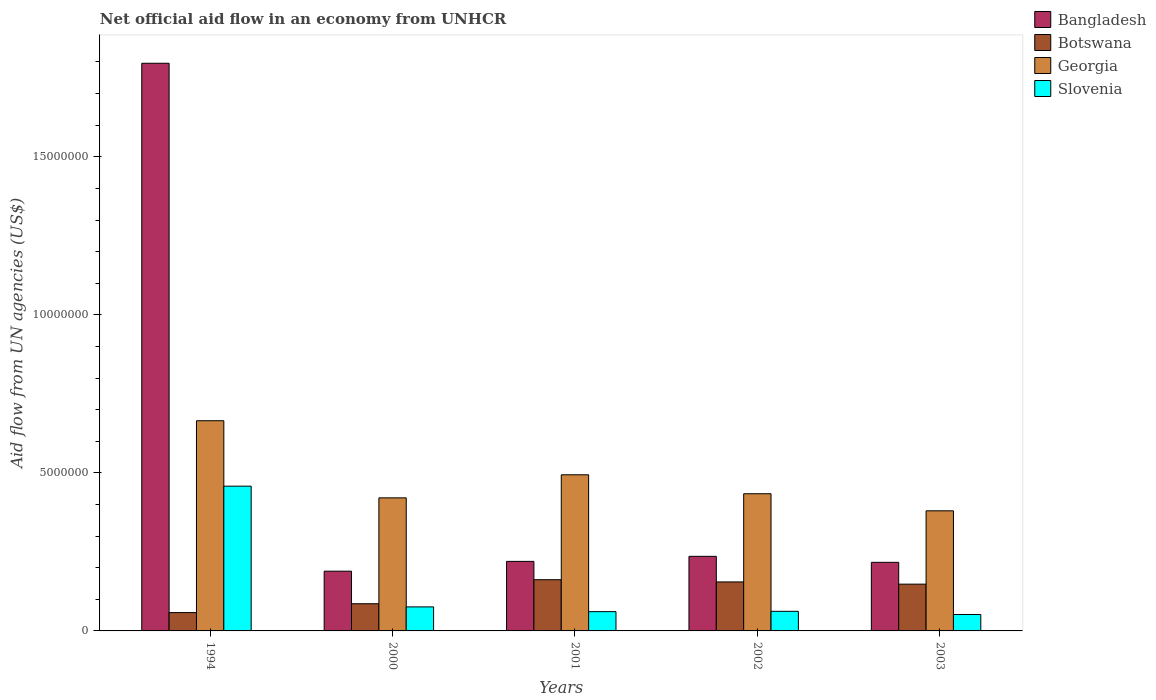How many groups of bars are there?
Your response must be concise. 5. Are the number of bars per tick equal to the number of legend labels?
Provide a succinct answer. Yes. Are the number of bars on each tick of the X-axis equal?
Provide a succinct answer. Yes. In how many cases, is the number of bars for a given year not equal to the number of legend labels?
Provide a short and direct response. 0. What is the net official aid flow in Bangladesh in 2002?
Keep it short and to the point. 2.36e+06. Across all years, what is the maximum net official aid flow in Botswana?
Give a very brief answer. 1.62e+06. Across all years, what is the minimum net official aid flow in Bangladesh?
Provide a succinct answer. 1.89e+06. In which year was the net official aid flow in Georgia maximum?
Your answer should be very brief. 1994. In which year was the net official aid flow in Slovenia minimum?
Your answer should be compact. 2003. What is the total net official aid flow in Botswana in the graph?
Provide a succinct answer. 6.09e+06. What is the difference between the net official aid flow in Georgia in 1994 and that in 2001?
Ensure brevity in your answer.  1.71e+06. What is the difference between the net official aid flow in Slovenia in 2000 and the net official aid flow in Botswana in 1994?
Offer a very short reply. 1.80e+05. What is the average net official aid flow in Slovenia per year?
Offer a terse response. 1.42e+06. In the year 2003, what is the difference between the net official aid flow in Slovenia and net official aid flow in Botswana?
Your response must be concise. -9.60e+05. In how many years, is the net official aid flow in Slovenia greater than 4000000 US$?
Your answer should be very brief. 1. What is the ratio of the net official aid flow in Georgia in 2000 to that in 2002?
Provide a succinct answer. 0.97. What is the difference between the highest and the second highest net official aid flow in Georgia?
Keep it short and to the point. 1.71e+06. What is the difference between the highest and the lowest net official aid flow in Georgia?
Provide a short and direct response. 2.85e+06. Is the sum of the net official aid flow in Slovenia in 2000 and 2003 greater than the maximum net official aid flow in Georgia across all years?
Keep it short and to the point. No. What does the 3rd bar from the left in 2002 represents?
Your response must be concise. Georgia. Is it the case that in every year, the sum of the net official aid flow in Slovenia and net official aid flow in Botswana is greater than the net official aid flow in Bangladesh?
Keep it short and to the point. No. How many bars are there?
Your answer should be compact. 20. What is the difference between two consecutive major ticks on the Y-axis?
Offer a very short reply. 5.00e+06. Are the values on the major ticks of Y-axis written in scientific E-notation?
Offer a very short reply. No. Where does the legend appear in the graph?
Make the answer very short. Top right. What is the title of the graph?
Provide a succinct answer. Net official aid flow in an economy from UNHCR. What is the label or title of the X-axis?
Keep it short and to the point. Years. What is the label or title of the Y-axis?
Offer a very short reply. Aid flow from UN agencies (US$). What is the Aid flow from UN agencies (US$) in Bangladesh in 1994?
Give a very brief answer. 1.80e+07. What is the Aid flow from UN agencies (US$) of Botswana in 1994?
Your response must be concise. 5.80e+05. What is the Aid flow from UN agencies (US$) of Georgia in 1994?
Provide a succinct answer. 6.65e+06. What is the Aid flow from UN agencies (US$) in Slovenia in 1994?
Make the answer very short. 4.58e+06. What is the Aid flow from UN agencies (US$) in Bangladesh in 2000?
Keep it short and to the point. 1.89e+06. What is the Aid flow from UN agencies (US$) in Botswana in 2000?
Offer a terse response. 8.60e+05. What is the Aid flow from UN agencies (US$) in Georgia in 2000?
Give a very brief answer. 4.21e+06. What is the Aid flow from UN agencies (US$) in Slovenia in 2000?
Offer a terse response. 7.60e+05. What is the Aid flow from UN agencies (US$) in Bangladesh in 2001?
Give a very brief answer. 2.20e+06. What is the Aid flow from UN agencies (US$) in Botswana in 2001?
Ensure brevity in your answer.  1.62e+06. What is the Aid flow from UN agencies (US$) of Georgia in 2001?
Keep it short and to the point. 4.94e+06. What is the Aid flow from UN agencies (US$) in Slovenia in 2001?
Provide a short and direct response. 6.10e+05. What is the Aid flow from UN agencies (US$) of Bangladesh in 2002?
Your answer should be compact. 2.36e+06. What is the Aid flow from UN agencies (US$) in Botswana in 2002?
Keep it short and to the point. 1.55e+06. What is the Aid flow from UN agencies (US$) of Georgia in 2002?
Offer a very short reply. 4.34e+06. What is the Aid flow from UN agencies (US$) in Slovenia in 2002?
Your answer should be compact. 6.20e+05. What is the Aid flow from UN agencies (US$) of Bangladesh in 2003?
Provide a succinct answer. 2.17e+06. What is the Aid flow from UN agencies (US$) of Botswana in 2003?
Your answer should be compact. 1.48e+06. What is the Aid flow from UN agencies (US$) of Georgia in 2003?
Provide a succinct answer. 3.80e+06. What is the Aid flow from UN agencies (US$) in Slovenia in 2003?
Your response must be concise. 5.20e+05. Across all years, what is the maximum Aid flow from UN agencies (US$) of Bangladesh?
Make the answer very short. 1.80e+07. Across all years, what is the maximum Aid flow from UN agencies (US$) of Botswana?
Offer a terse response. 1.62e+06. Across all years, what is the maximum Aid flow from UN agencies (US$) of Georgia?
Give a very brief answer. 6.65e+06. Across all years, what is the maximum Aid flow from UN agencies (US$) in Slovenia?
Ensure brevity in your answer.  4.58e+06. Across all years, what is the minimum Aid flow from UN agencies (US$) of Bangladesh?
Your answer should be compact. 1.89e+06. Across all years, what is the minimum Aid flow from UN agencies (US$) of Botswana?
Keep it short and to the point. 5.80e+05. Across all years, what is the minimum Aid flow from UN agencies (US$) in Georgia?
Offer a very short reply. 3.80e+06. Across all years, what is the minimum Aid flow from UN agencies (US$) in Slovenia?
Provide a succinct answer. 5.20e+05. What is the total Aid flow from UN agencies (US$) in Bangladesh in the graph?
Give a very brief answer. 2.66e+07. What is the total Aid flow from UN agencies (US$) of Botswana in the graph?
Provide a succinct answer. 6.09e+06. What is the total Aid flow from UN agencies (US$) of Georgia in the graph?
Make the answer very short. 2.39e+07. What is the total Aid flow from UN agencies (US$) of Slovenia in the graph?
Your response must be concise. 7.09e+06. What is the difference between the Aid flow from UN agencies (US$) of Bangladesh in 1994 and that in 2000?
Provide a succinct answer. 1.61e+07. What is the difference between the Aid flow from UN agencies (US$) in Botswana in 1994 and that in 2000?
Make the answer very short. -2.80e+05. What is the difference between the Aid flow from UN agencies (US$) in Georgia in 1994 and that in 2000?
Your answer should be very brief. 2.44e+06. What is the difference between the Aid flow from UN agencies (US$) of Slovenia in 1994 and that in 2000?
Your answer should be very brief. 3.82e+06. What is the difference between the Aid flow from UN agencies (US$) of Bangladesh in 1994 and that in 2001?
Your answer should be very brief. 1.58e+07. What is the difference between the Aid flow from UN agencies (US$) of Botswana in 1994 and that in 2001?
Provide a short and direct response. -1.04e+06. What is the difference between the Aid flow from UN agencies (US$) in Georgia in 1994 and that in 2001?
Offer a terse response. 1.71e+06. What is the difference between the Aid flow from UN agencies (US$) of Slovenia in 1994 and that in 2001?
Keep it short and to the point. 3.97e+06. What is the difference between the Aid flow from UN agencies (US$) of Bangladesh in 1994 and that in 2002?
Your response must be concise. 1.56e+07. What is the difference between the Aid flow from UN agencies (US$) of Botswana in 1994 and that in 2002?
Offer a very short reply. -9.70e+05. What is the difference between the Aid flow from UN agencies (US$) of Georgia in 1994 and that in 2002?
Your answer should be very brief. 2.31e+06. What is the difference between the Aid flow from UN agencies (US$) of Slovenia in 1994 and that in 2002?
Ensure brevity in your answer.  3.96e+06. What is the difference between the Aid flow from UN agencies (US$) in Bangladesh in 1994 and that in 2003?
Offer a terse response. 1.58e+07. What is the difference between the Aid flow from UN agencies (US$) in Botswana in 1994 and that in 2003?
Keep it short and to the point. -9.00e+05. What is the difference between the Aid flow from UN agencies (US$) in Georgia in 1994 and that in 2003?
Ensure brevity in your answer.  2.85e+06. What is the difference between the Aid flow from UN agencies (US$) of Slovenia in 1994 and that in 2003?
Make the answer very short. 4.06e+06. What is the difference between the Aid flow from UN agencies (US$) of Bangladesh in 2000 and that in 2001?
Give a very brief answer. -3.10e+05. What is the difference between the Aid flow from UN agencies (US$) of Botswana in 2000 and that in 2001?
Keep it short and to the point. -7.60e+05. What is the difference between the Aid flow from UN agencies (US$) in Georgia in 2000 and that in 2001?
Your answer should be compact. -7.30e+05. What is the difference between the Aid flow from UN agencies (US$) in Slovenia in 2000 and that in 2001?
Provide a short and direct response. 1.50e+05. What is the difference between the Aid flow from UN agencies (US$) in Bangladesh in 2000 and that in 2002?
Your answer should be very brief. -4.70e+05. What is the difference between the Aid flow from UN agencies (US$) in Botswana in 2000 and that in 2002?
Provide a short and direct response. -6.90e+05. What is the difference between the Aid flow from UN agencies (US$) in Georgia in 2000 and that in 2002?
Offer a very short reply. -1.30e+05. What is the difference between the Aid flow from UN agencies (US$) of Slovenia in 2000 and that in 2002?
Your answer should be very brief. 1.40e+05. What is the difference between the Aid flow from UN agencies (US$) of Bangladesh in 2000 and that in 2003?
Offer a terse response. -2.80e+05. What is the difference between the Aid flow from UN agencies (US$) of Botswana in 2000 and that in 2003?
Offer a terse response. -6.20e+05. What is the difference between the Aid flow from UN agencies (US$) in Georgia in 2000 and that in 2003?
Your response must be concise. 4.10e+05. What is the difference between the Aid flow from UN agencies (US$) of Bangladesh in 2001 and that in 2002?
Provide a succinct answer. -1.60e+05. What is the difference between the Aid flow from UN agencies (US$) in Botswana in 2001 and that in 2002?
Make the answer very short. 7.00e+04. What is the difference between the Aid flow from UN agencies (US$) of Georgia in 2001 and that in 2002?
Offer a very short reply. 6.00e+05. What is the difference between the Aid flow from UN agencies (US$) of Botswana in 2001 and that in 2003?
Keep it short and to the point. 1.40e+05. What is the difference between the Aid flow from UN agencies (US$) of Georgia in 2001 and that in 2003?
Ensure brevity in your answer.  1.14e+06. What is the difference between the Aid flow from UN agencies (US$) of Bangladesh in 2002 and that in 2003?
Offer a terse response. 1.90e+05. What is the difference between the Aid flow from UN agencies (US$) in Botswana in 2002 and that in 2003?
Provide a short and direct response. 7.00e+04. What is the difference between the Aid flow from UN agencies (US$) in Georgia in 2002 and that in 2003?
Ensure brevity in your answer.  5.40e+05. What is the difference between the Aid flow from UN agencies (US$) in Slovenia in 2002 and that in 2003?
Keep it short and to the point. 1.00e+05. What is the difference between the Aid flow from UN agencies (US$) in Bangladesh in 1994 and the Aid flow from UN agencies (US$) in Botswana in 2000?
Ensure brevity in your answer.  1.71e+07. What is the difference between the Aid flow from UN agencies (US$) of Bangladesh in 1994 and the Aid flow from UN agencies (US$) of Georgia in 2000?
Your answer should be very brief. 1.38e+07. What is the difference between the Aid flow from UN agencies (US$) of Bangladesh in 1994 and the Aid flow from UN agencies (US$) of Slovenia in 2000?
Your answer should be very brief. 1.72e+07. What is the difference between the Aid flow from UN agencies (US$) in Botswana in 1994 and the Aid flow from UN agencies (US$) in Georgia in 2000?
Your answer should be very brief. -3.63e+06. What is the difference between the Aid flow from UN agencies (US$) of Georgia in 1994 and the Aid flow from UN agencies (US$) of Slovenia in 2000?
Provide a succinct answer. 5.89e+06. What is the difference between the Aid flow from UN agencies (US$) in Bangladesh in 1994 and the Aid flow from UN agencies (US$) in Botswana in 2001?
Your answer should be compact. 1.63e+07. What is the difference between the Aid flow from UN agencies (US$) in Bangladesh in 1994 and the Aid flow from UN agencies (US$) in Georgia in 2001?
Your answer should be very brief. 1.30e+07. What is the difference between the Aid flow from UN agencies (US$) in Bangladesh in 1994 and the Aid flow from UN agencies (US$) in Slovenia in 2001?
Offer a terse response. 1.74e+07. What is the difference between the Aid flow from UN agencies (US$) in Botswana in 1994 and the Aid flow from UN agencies (US$) in Georgia in 2001?
Provide a succinct answer. -4.36e+06. What is the difference between the Aid flow from UN agencies (US$) in Botswana in 1994 and the Aid flow from UN agencies (US$) in Slovenia in 2001?
Offer a very short reply. -3.00e+04. What is the difference between the Aid flow from UN agencies (US$) of Georgia in 1994 and the Aid flow from UN agencies (US$) of Slovenia in 2001?
Your response must be concise. 6.04e+06. What is the difference between the Aid flow from UN agencies (US$) of Bangladesh in 1994 and the Aid flow from UN agencies (US$) of Botswana in 2002?
Offer a terse response. 1.64e+07. What is the difference between the Aid flow from UN agencies (US$) in Bangladesh in 1994 and the Aid flow from UN agencies (US$) in Georgia in 2002?
Provide a succinct answer. 1.36e+07. What is the difference between the Aid flow from UN agencies (US$) in Bangladesh in 1994 and the Aid flow from UN agencies (US$) in Slovenia in 2002?
Keep it short and to the point. 1.73e+07. What is the difference between the Aid flow from UN agencies (US$) in Botswana in 1994 and the Aid flow from UN agencies (US$) in Georgia in 2002?
Make the answer very short. -3.76e+06. What is the difference between the Aid flow from UN agencies (US$) in Georgia in 1994 and the Aid flow from UN agencies (US$) in Slovenia in 2002?
Ensure brevity in your answer.  6.03e+06. What is the difference between the Aid flow from UN agencies (US$) of Bangladesh in 1994 and the Aid flow from UN agencies (US$) of Botswana in 2003?
Give a very brief answer. 1.65e+07. What is the difference between the Aid flow from UN agencies (US$) of Bangladesh in 1994 and the Aid flow from UN agencies (US$) of Georgia in 2003?
Your answer should be very brief. 1.42e+07. What is the difference between the Aid flow from UN agencies (US$) in Bangladesh in 1994 and the Aid flow from UN agencies (US$) in Slovenia in 2003?
Your answer should be compact. 1.74e+07. What is the difference between the Aid flow from UN agencies (US$) of Botswana in 1994 and the Aid flow from UN agencies (US$) of Georgia in 2003?
Your answer should be very brief. -3.22e+06. What is the difference between the Aid flow from UN agencies (US$) in Botswana in 1994 and the Aid flow from UN agencies (US$) in Slovenia in 2003?
Your response must be concise. 6.00e+04. What is the difference between the Aid flow from UN agencies (US$) in Georgia in 1994 and the Aid flow from UN agencies (US$) in Slovenia in 2003?
Your answer should be compact. 6.13e+06. What is the difference between the Aid flow from UN agencies (US$) of Bangladesh in 2000 and the Aid flow from UN agencies (US$) of Georgia in 2001?
Ensure brevity in your answer.  -3.05e+06. What is the difference between the Aid flow from UN agencies (US$) of Bangladesh in 2000 and the Aid flow from UN agencies (US$) of Slovenia in 2001?
Your answer should be compact. 1.28e+06. What is the difference between the Aid flow from UN agencies (US$) of Botswana in 2000 and the Aid flow from UN agencies (US$) of Georgia in 2001?
Offer a very short reply. -4.08e+06. What is the difference between the Aid flow from UN agencies (US$) of Georgia in 2000 and the Aid flow from UN agencies (US$) of Slovenia in 2001?
Offer a terse response. 3.60e+06. What is the difference between the Aid flow from UN agencies (US$) of Bangladesh in 2000 and the Aid flow from UN agencies (US$) of Georgia in 2002?
Offer a very short reply. -2.45e+06. What is the difference between the Aid flow from UN agencies (US$) of Bangladesh in 2000 and the Aid flow from UN agencies (US$) of Slovenia in 2002?
Give a very brief answer. 1.27e+06. What is the difference between the Aid flow from UN agencies (US$) of Botswana in 2000 and the Aid flow from UN agencies (US$) of Georgia in 2002?
Ensure brevity in your answer.  -3.48e+06. What is the difference between the Aid flow from UN agencies (US$) of Botswana in 2000 and the Aid flow from UN agencies (US$) of Slovenia in 2002?
Your answer should be very brief. 2.40e+05. What is the difference between the Aid flow from UN agencies (US$) of Georgia in 2000 and the Aid flow from UN agencies (US$) of Slovenia in 2002?
Provide a short and direct response. 3.59e+06. What is the difference between the Aid flow from UN agencies (US$) of Bangladesh in 2000 and the Aid flow from UN agencies (US$) of Georgia in 2003?
Offer a very short reply. -1.91e+06. What is the difference between the Aid flow from UN agencies (US$) of Bangladesh in 2000 and the Aid flow from UN agencies (US$) of Slovenia in 2003?
Your answer should be very brief. 1.37e+06. What is the difference between the Aid flow from UN agencies (US$) of Botswana in 2000 and the Aid flow from UN agencies (US$) of Georgia in 2003?
Provide a short and direct response. -2.94e+06. What is the difference between the Aid flow from UN agencies (US$) of Georgia in 2000 and the Aid flow from UN agencies (US$) of Slovenia in 2003?
Your response must be concise. 3.69e+06. What is the difference between the Aid flow from UN agencies (US$) in Bangladesh in 2001 and the Aid flow from UN agencies (US$) in Botswana in 2002?
Provide a short and direct response. 6.50e+05. What is the difference between the Aid flow from UN agencies (US$) in Bangladesh in 2001 and the Aid flow from UN agencies (US$) in Georgia in 2002?
Make the answer very short. -2.14e+06. What is the difference between the Aid flow from UN agencies (US$) of Bangladesh in 2001 and the Aid flow from UN agencies (US$) of Slovenia in 2002?
Provide a short and direct response. 1.58e+06. What is the difference between the Aid flow from UN agencies (US$) of Botswana in 2001 and the Aid flow from UN agencies (US$) of Georgia in 2002?
Your response must be concise. -2.72e+06. What is the difference between the Aid flow from UN agencies (US$) in Botswana in 2001 and the Aid flow from UN agencies (US$) in Slovenia in 2002?
Your response must be concise. 1.00e+06. What is the difference between the Aid flow from UN agencies (US$) of Georgia in 2001 and the Aid flow from UN agencies (US$) of Slovenia in 2002?
Provide a succinct answer. 4.32e+06. What is the difference between the Aid flow from UN agencies (US$) in Bangladesh in 2001 and the Aid flow from UN agencies (US$) in Botswana in 2003?
Give a very brief answer. 7.20e+05. What is the difference between the Aid flow from UN agencies (US$) in Bangladesh in 2001 and the Aid flow from UN agencies (US$) in Georgia in 2003?
Offer a terse response. -1.60e+06. What is the difference between the Aid flow from UN agencies (US$) in Bangladesh in 2001 and the Aid flow from UN agencies (US$) in Slovenia in 2003?
Offer a very short reply. 1.68e+06. What is the difference between the Aid flow from UN agencies (US$) of Botswana in 2001 and the Aid flow from UN agencies (US$) of Georgia in 2003?
Provide a short and direct response. -2.18e+06. What is the difference between the Aid flow from UN agencies (US$) of Botswana in 2001 and the Aid flow from UN agencies (US$) of Slovenia in 2003?
Offer a terse response. 1.10e+06. What is the difference between the Aid flow from UN agencies (US$) in Georgia in 2001 and the Aid flow from UN agencies (US$) in Slovenia in 2003?
Your answer should be very brief. 4.42e+06. What is the difference between the Aid flow from UN agencies (US$) in Bangladesh in 2002 and the Aid flow from UN agencies (US$) in Botswana in 2003?
Your response must be concise. 8.80e+05. What is the difference between the Aid flow from UN agencies (US$) of Bangladesh in 2002 and the Aid flow from UN agencies (US$) of Georgia in 2003?
Keep it short and to the point. -1.44e+06. What is the difference between the Aid flow from UN agencies (US$) of Bangladesh in 2002 and the Aid flow from UN agencies (US$) of Slovenia in 2003?
Ensure brevity in your answer.  1.84e+06. What is the difference between the Aid flow from UN agencies (US$) of Botswana in 2002 and the Aid flow from UN agencies (US$) of Georgia in 2003?
Offer a very short reply. -2.25e+06. What is the difference between the Aid flow from UN agencies (US$) in Botswana in 2002 and the Aid flow from UN agencies (US$) in Slovenia in 2003?
Provide a succinct answer. 1.03e+06. What is the difference between the Aid flow from UN agencies (US$) in Georgia in 2002 and the Aid flow from UN agencies (US$) in Slovenia in 2003?
Keep it short and to the point. 3.82e+06. What is the average Aid flow from UN agencies (US$) of Bangladesh per year?
Your answer should be very brief. 5.32e+06. What is the average Aid flow from UN agencies (US$) in Botswana per year?
Your answer should be compact. 1.22e+06. What is the average Aid flow from UN agencies (US$) in Georgia per year?
Offer a very short reply. 4.79e+06. What is the average Aid flow from UN agencies (US$) of Slovenia per year?
Ensure brevity in your answer.  1.42e+06. In the year 1994, what is the difference between the Aid flow from UN agencies (US$) in Bangladesh and Aid flow from UN agencies (US$) in Botswana?
Keep it short and to the point. 1.74e+07. In the year 1994, what is the difference between the Aid flow from UN agencies (US$) in Bangladesh and Aid flow from UN agencies (US$) in Georgia?
Provide a short and direct response. 1.13e+07. In the year 1994, what is the difference between the Aid flow from UN agencies (US$) of Bangladesh and Aid flow from UN agencies (US$) of Slovenia?
Ensure brevity in your answer.  1.34e+07. In the year 1994, what is the difference between the Aid flow from UN agencies (US$) of Botswana and Aid flow from UN agencies (US$) of Georgia?
Provide a short and direct response. -6.07e+06. In the year 1994, what is the difference between the Aid flow from UN agencies (US$) of Botswana and Aid flow from UN agencies (US$) of Slovenia?
Your answer should be very brief. -4.00e+06. In the year 1994, what is the difference between the Aid flow from UN agencies (US$) in Georgia and Aid flow from UN agencies (US$) in Slovenia?
Give a very brief answer. 2.07e+06. In the year 2000, what is the difference between the Aid flow from UN agencies (US$) of Bangladesh and Aid flow from UN agencies (US$) of Botswana?
Provide a short and direct response. 1.03e+06. In the year 2000, what is the difference between the Aid flow from UN agencies (US$) of Bangladesh and Aid flow from UN agencies (US$) of Georgia?
Provide a short and direct response. -2.32e+06. In the year 2000, what is the difference between the Aid flow from UN agencies (US$) in Bangladesh and Aid flow from UN agencies (US$) in Slovenia?
Offer a very short reply. 1.13e+06. In the year 2000, what is the difference between the Aid flow from UN agencies (US$) of Botswana and Aid flow from UN agencies (US$) of Georgia?
Your answer should be compact. -3.35e+06. In the year 2000, what is the difference between the Aid flow from UN agencies (US$) of Georgia and Aid flow from UN agencies (US$) of Slovenia?
Ensure brevity in your answer.  3.45e+06. In the year 2001, what is the difference between the Aid flow from UN agencies (US$) of Bangladesh and Aid flow from UN agencies (US$) of Botswana?
Provide a succinct answer. 5.80e+05. In the year 2001, what is the difference between the Aid flow from UN agencies (US$) of Bangladesh and Aid flow from UN agencies (US$) of Georgia?
Your response must be concise. -2.74e+06. In the year 2001, what is the difference between the Aid flow from UN agencies (US$) of Bangladesh and Aid flow from UN agencies (US$) of Slovenia?
Give a very brief answer. 1.59e+06. In the year 2001, what is the difference between the Aid flow from UN agencies (US$) of Botswana and Aid flow from UN agencies (US$) of Georgia?
Provide a succinct answer. -3.32e+06. In the year 2001, what is the difference between the Aid flow from UN agencies (US$) in Botswana and Aid flow from UN agencies (US$) in Slovenia?
Offer a terse response. 1.01e+06. In the year 2001, what is the difference between the Aid flow from UN agencies (US$) in Georgia and Aid flow from UN agencies (US$) in Slovenia?
Provide a short and direct response. 4.33e+06. In the year 2002, what is the difference between the Aid flow from UN agencies (US$) of Bangladesh and Aid flow from UN agencies (US$) of Botswana?
Ensure brevity in your answer.  8.10e+05. In the year 2002, what is the difference between the Aid flow from UN agencies (US$) of Bangladesh and Aid flow from UN agencies (US$) of Georgia?
Offer a terse response. -1.98e+06. In the year 2002, what is the difference between the Aid flow from UN agencies (US$) in Bangladesh and Aid flow from UN agencies (US$) in Slovenia?
Your answer should be very brief. 1.74e+06. In the year 2002, what is the difference between the Aid flow from UN agencies (US$) of Botswana and Aid flow from UN agencies (US$) of Georgia?
Ensure brevity in your answer.  -2.79e+06. In the year 2002, what is the difference between the Aid flow from UN agencies (US$) of Botswana and Aid flow from UN agencies (US$) of Slovenia?
Give a very brief answer. 9.30e+05. In the year 2002, what is the difference between the Aid flow from UN agencies (US$) of Georgia and Aid flow from UN agencies (US$) of Slovenia?
Keep it short and to the point. 3.72e+06. In the year 2003, what is the difference between the Aid flow from UN agencies (US$) of Bangladesh and Aid flow from UN agencies (US$) of Botswana?
Your response must be concise. 6.90e+05. In the year 2003, what is the difference between the Aid flow from UN agencies (US$) in Bangladesh and Aid flow from UN agencies (US$) in Georgia?
Provide a short and direct response. -1.63e+06. In the year 2003, what is the difference between the Aid flow from UN agencies (US$) of Bangladesh and Aid flow from UN agencies (US$) of Slovenia?
Provide a short and direct response. 1.65e+06. In the year 2003, what is the difference between the Aid flow from UN agencies (US$) in Botswana and Aid flow from UN agencies (US$) in Georgia?
Keep it short and to the point. -2.32e+06. In the year 2003, what is the difference between the Aid flow from UN agencies (US$) of Botswana and Aid flow from UN agencies (US$) of Slovenia?
Your response must be concise. 9.60e+05. In the year 2003, what is the difference between the Aid flow from UN agencies (US$) in Georgia and Aid flow from UN agencies (US$) in Slovenia?
Your answer should be very brief. 3.28e+06. What is the ratio of the Aid flow from UN agencies (US$) in Bangladesh in 1994 to that in 2000?
Offer a terse response. 9.5. What is the ratio of the Aid flow from UN agencies (US$) of Botswana in 1994 to that in 2000?
Ensure brevity in your answer.  0.67. What is the ratio of the Aid flow from UN agencies (US$) in Georgia in 1994 to that in 2000?
Your answer should be compact. 1.58. What is the ratio of the Aid flow from UN agencies (US$) of Slovenia in 1994 to that in 2000?
Ensure brevity in your answer.  6.03. What is the ratio of the Aid flow from UN agencies (US$) of Bangladesh in 1994 to that in 2001?
Give a very brief answer. 8.16. What is the ratio of the Aid flow from UN agencies (US$) of Botswana in 1994 to that in 2001?
Your answer should be compact. 0.36. What is the ratio of the Aid flow from UN agencies (US$) of Georgia in 1994 to that in 2001?
Offer a terse response. 1.35. What is the ratio of the Aid flow from UN agencies (US$) of Slovenia in 1994 to that in 2001?
Your response must be concise. 7.51. What is the ratio of the Aid flow from UN agencies (US$) in Bangladesh in 1994 to that in 2002?
Provide a succinct answer. 7.61. What is the ratio of the Aid flow from UN agencies (US$) of Botswana in 1994 to that in 2002?
Provide a succinct answer. 0.37. What is the ratio of the Aid flow from UN agencies (US$) in Georgia in 1994 to that in 2002?
Your answer should be compact. 1.53. What is the ratio of the Aid flow from UN agencies (US$) in Slovenia in 1994 to that in 2002?
Make the answer very short. 7.39. What is the ratio of the Aid flow from UN agencies (US$) in Bangladesh in 1994 to that in 2003?
Keep it short and to the point. 8.28. What is the ratio of the Aid flow from UN agencies (US$) of Botswana in 1994 to that in 2003?
Your answer should be very brief. 0.39. What is the ratio of the Aid flow from UN agencies (US$) in Slovenia in 1994 to that in 2003?
Keep it short and to the point. 8.81. What is the ratio of the Aid flow from UN agencies (US$) of Bangladesh in 2000 to that in 2001?
Ensure brevity in your answer.  0.86. What is the ratio of the Aid flow from UN agencies (US$) of Botswana in 2000 to that in 2001?
Provide a succinct answer. 0.53. What is the ratio of the Aid flow from UN agencies (US$) of Georgia in 2000 to that in 2001?
Offer a terse response. 0.85. What is the ratio of the Aid flow from UN agencies (US$) of Slovenia in 2000 to that in 2001?
Your answer should be very brief. 1.25. What is the ratio of the Aid flow from UN agencies (US$) of Bangladesh in 2000 to that in 2002?
Provide a short and direct response. 0.8. What is the ratio of the Aid flow from UN agencies (US$) in Botswana in 2000 to that in 2002?
Give a very brief answer. 0.55. What is the ratio of the Aid flow from UN agencies (US$) in Slovenia in 2000 to that in 2002?
Offer a very short reply. 1.23. What is the ratio of the Aid flow from UN agencies (US$) in Bangladesh in 2000 to that in 2003?
Give a very brief answer. 0.87. What is the ratio of the Aid flow from UN agencies (US$) of Botswana in 2000 to that in 2003?
Your answer should be very brief. 0.58. What is the ratio of the Aid flow from UN agencies (US$) in Georgia in 2000 to that in 2003?
Ensure brevity in your answer.  1.11. What is the ratio of the Aid flow from UN agencies (US$) of Slovenia in 2000 to that in 2003?
Provide a short and direct response. 1.46. What is the ratio of the Aid flow from UN agencies (US$) in Bangladesh in 2001 to that in 2002?
Make the answer very short. 0.93. What is the ratio of the Aid flow from UN agencies (US$) of Botswana in 2001 to that in 2002?
Your answer should be compact. 1.05. What is the ratio of the Aid flow from UN agencies (US$) of Georgia in 2001 to that in 2002?
Offer a terse response. 1.14. What is the ratio of the Aid flow from UN agencies (US$) in Slovenia in 2001 to that in 2002?
Your response must be concise. 0.98. What is the ratio of the Aid flow from UN agencies (US$) in Bangladesh in 2001 to that in 2003?
Your response must be concise. 1.01. What is the ratio of the Aid flow from UN agencies (US$) in Botswana in 2001 to that in 2003?
Your response must be concise. 1.09. What is the ratio of the Aid flow from UN agencies (US$) in Slovenia in 2001 to that in 2003?
Ensure brevity in your answer.  1.17. What is the ratio of the Aid flow from UN agencies (US$) in Bangladesh in 2002 to that in 2003?
Your answer should be compact. 1.09. What is the ratio of the Aid flow from UN agencies (US$) in Botswana in 2002 to that in 2003?
Offer a terse response. 1.05. What is the ratio of the Aid flow from UN agencies (US$) of Georgia in 2002 to that in 2003?
Give a very brief answer. 1.14. What is the ratio of the Aid flow from UN agencies (US$) in Slovenia in 2002 to that in 2003?
Your answer should be compact. 1.19. What is the difference between the highest and the second highest Aid flow from UN agencies (US$) of Bangladesh?
Provide a succinct answer. 1.56e+07. What is the difference between the highest and the second highest Aid flow from UN agencies (US$) of Georgia?
Offer a terse response. 1.71e+06. What is the difference between the highest and the second highest Aid flow from UN agencies (US$) of Slovenia?
Offer a terse response. 3.82e+06. What is the difference between the highest and the lowest Aid flow from UN agencies (US$) in Bangladesh?
Make the answer very short. 1.61e+07. What is the difference between the highest and the lowest Aid flow from UN agencies (US$) of Botswana?
Offer a terse response. 1.04e+06. What is the difference between the highest and the lowest Aid flow from UN agencies (US$) of Georgia?
Offer a very short reply. 2.85e+06. What is the difference between the highest and the lowest Aid flow from UN agencies (US$) in Slovenia?
Ensure brevity in your answer.  4.06e+06. 